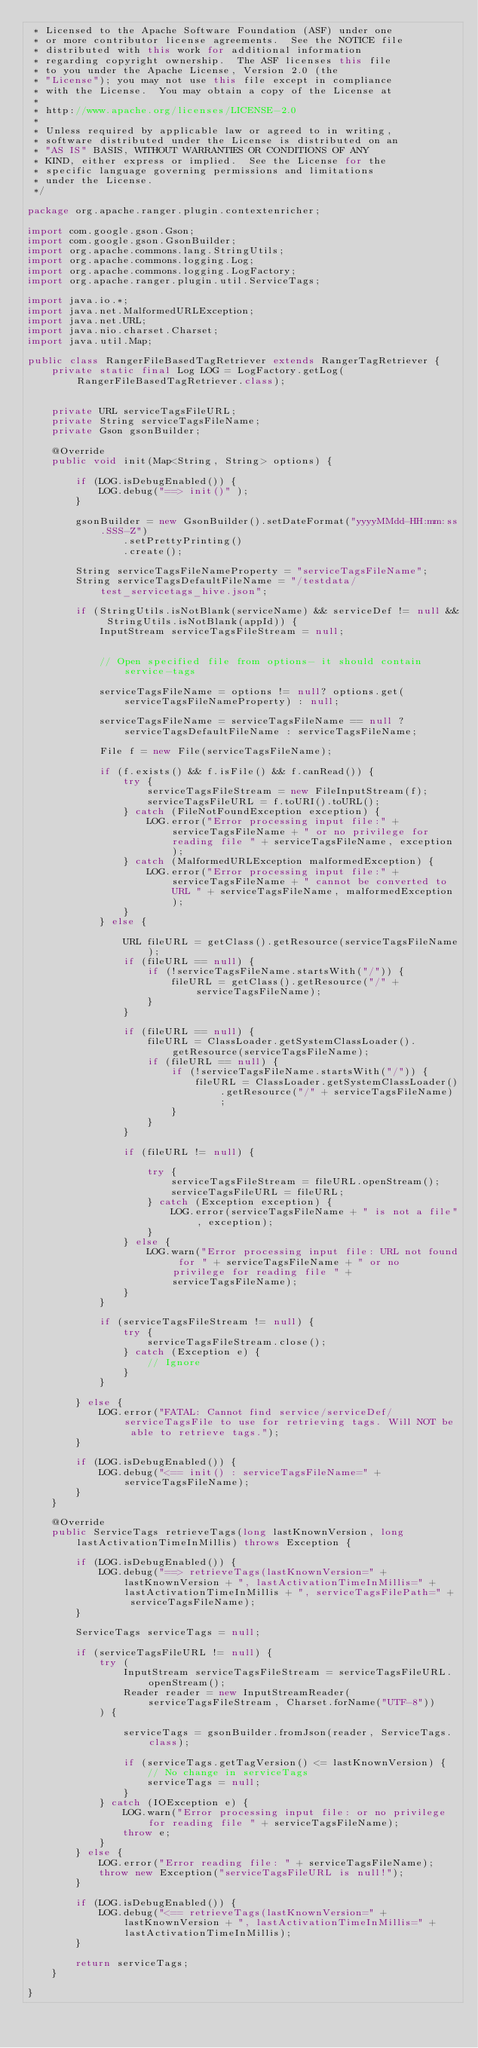Convert code to text. <code><loc_0><loc_0><loc_500><loc_500><_Java_> * Licensed to the Apache Software Foundation (ASF) under one
 * or more contributor license agreements.  See the NOTICE file
 * distributed with this work for additional information
 * regarding copyright ownership.  The ASF licenses this file
 * to you under the Apache License, Version 2.0 (the
 * "License"); you may not use this file except in compliance
 * with the License.  You may obtain a copy of the License at
 *
 * http://www.apache.org/licenses/LICENSE-2.0
 *
 * Unless required by applicable law or agreed to in writing,
 * software distributed under the License is distributed on an
 * "AS IS" BASIS, WITHOUT WARRANTIES OR CONDITIONS OF ANY
 * KIND, either express or implied.  See the License for the
 * specific language governing permissions and limitations
 * under the License.
 */

package org.apache.ranger.plugin.contextenricher;

import com.google.gson.Gson;
import com.google.gson.GsonBuilder;
import org.apache.commons.lang.StringUtils;
import org.apache.commons.logging.Log;
import org.apache.commons.logging.LogFactory;
import org.apache.ranger.plugin.util.ServiceTags;

import java.io.*;
import java.net.MalformedURLException;
import java.net.URL;
import java.nio.charset.Charset;
import java.util.Map;

public class RangerFileBasedTagRetriever extends RangerTagRetriever {
	private static final Log LOG = LogFactory.getLog(RangerFileBasedTagRetriever.class);


	private URL serviceTagsFileURL;
	private String serviceTagsFileName;
	private Gson gsonBuilder;

	@Override
	public void init(Map<String, String> options) {

		if (LOG.isDebugEnabled()) {
			LOG.debug("==> init()" );
		}

		gsonBuilder = new GsonBuilder().setDateFormat("yyyyMMdd-HH:mm:ss.SSS-Z")
				.setPrettyPrinting()
				.create();

		String serviceTagsFileNameProperty = "serviceTagsFileName";
		String serviceTagsDefaultFileName = "/testdata/test_servicetags_hive.json";

		if (StringUtils.isNotBlank(serviceName) && serviceDef != null && StringUtils.isNotBlank(appId)) {
			InputStream serviceTagsFileStream = null;


			// Open specified file from options- it should contain service-tags

			serviceTagsFileName = options != null? options.get(serviceTagsFileNameProperty) : null;

			serviceTagsFileName = serviceTagsFileName == null ? serviceTagsDefaultFileName : serviceTagsFileName;

			File f = new File(serviceTagsFileName);

			if (f.exists() && f.isFile() && f.canRead()) {
				try {
					serviceTagsFileStream = new FileInputStream(f);
					serviceTagsFileURL = f.toURI().toURL();
				} catch (FileNotFoundException exception) {
					LOG.error("Error processing input file:" + serviceTagsFileName + " or no privilege for reading file " + serviceTagsFileName, exception);
				} catch (MalformedURLException malformedException) {
					LOG.error("Error processing input file:" + serviceTagsFileName + " cannot be converted to URL " + serviceTagsFileName, malformedException);
				}
			} else {

				URL fileURL = getClass().getResource(serviceTagsFileName);
				if (fileURL == null) {
					if (!serviceTagsFileName.startsWith("/")) {
						fileURL = getClass().getResource("/" + serviceTagsFileName);
					}
				}

				if (fileURL == null) {
					fileURL = ClassLoader.getSystemClassLoader().getResource(serviceTagsFileName);
					if (fileURL == null) {
						if (!serviceTagsFileName.startsWith("/")) {
							fileURL = ClassLoader.getSystemClassLoader().getResource("/" + serviceTagsFileName);
						}
					}
				}

				if (fileURL != null) {

					try {
						serviceTagsFileStream = fileURL.openStream();
						serviceTagsFileURL = fileURL;
					} catch (Exception exception) {
						LOG.error(serviceTagsFileName + " is not a file", exception);
					}
				} else {
					LOG.warn("Error processing input file: URL not found for " + serviceTagsFileName + " or no privilege for reading file " + serviceTagsFileName);
				}
			}

			if (serviceTagsFileStream != null) {
				try {
					serviceTagsFileStream.close();
				} catch (Exception e) {
					// Ignore
				}
			}

		} else {
			LOG.error("FATAL: Cannot find service/serviceDef/serviceTagsFile to use for retrieving tags. Will NOT be able to retrieve tags.");
		}

		if (LOG.isDebugEnabled()) {
			LOG.debug("<== init() : serviceTagsFileName=" + serviceTagsFileName);
		}
	}

	@Override
	public ServiceTags retrieveTags(long lastKnownVersion, long lastActivationTimeInMillis) throws Exception {

		if (LOG.isDebugEnabled()) {
			LOG.debug("==> retrieveTags(lastKnownVersion=" + lastKnownVersion + ", lastActivationTimeInMillis=" + lastActivationTimeInMillis + ", serviceTagsFilePath=" + serviceTagsFileName);
		}

		ServiceTags serviceTags = null;

		if (serviceTagsFileURL != null) {
			try (
				InputStream serviceTagsFileStream = serviceTagsFileURL.openStream();
				Reader reader = new InputStreamReader(serviceTagsFileStream, Charset.forName("UTF-8"))
			) {

				serviceTags = gsonBuilder.fromJson(reader, ServiceTags.class);

				if (serviceTags.getTagVersion() <= lastKnownVersion) {
					// No change in serviceTags
					serviceTags = null;
				}
			} catch (IOException e) {
				LOG.warn("Error processing input file: or no privilege for reading file " + serviceTagsFileName);
				throw e;
			}
		} else {
			LOG.error("Error reading file: " + serviceTagsFileName);
			throw new Exception("serviceTagsFileURL is null!");
		}

		if (LOG.isDebugEnabled()) {
			LOG.debug("<== retrieveTags(lastKnownVersion=" + lastKnownVersion + ", lastActivationTimeInMillis=" + lastActivationTimeInMillis);
		}

		return serviceTags;
	}

}

</code> 